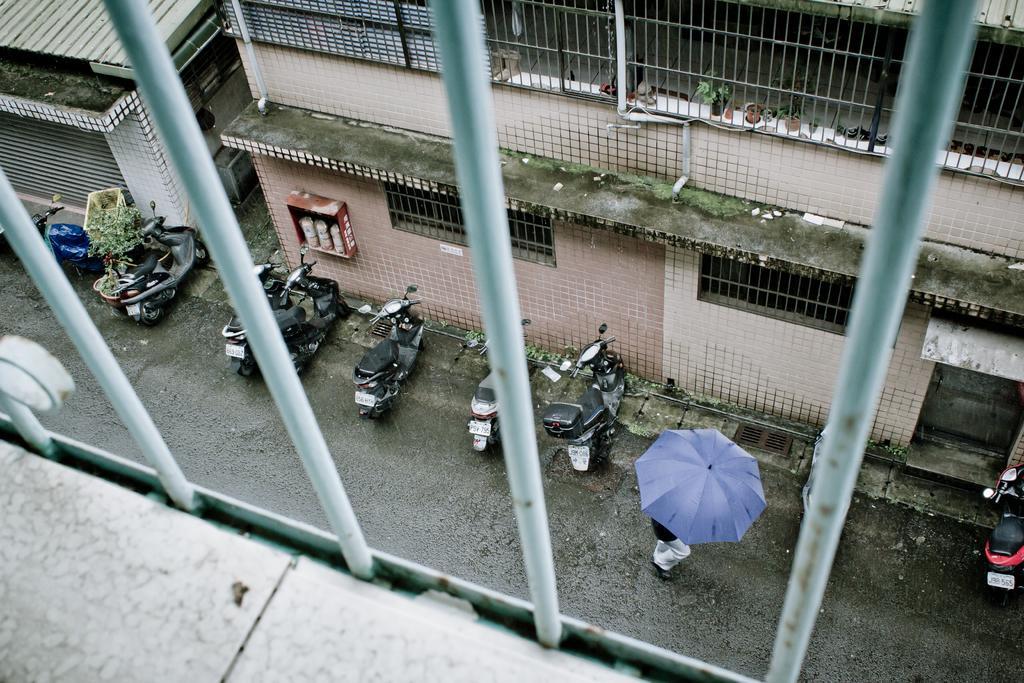How would you summarize this image in a sentence or two? In this image there are buildings and we can see motorcycles placed on the road. There is a person holding a umbrella and we can see grilles. 